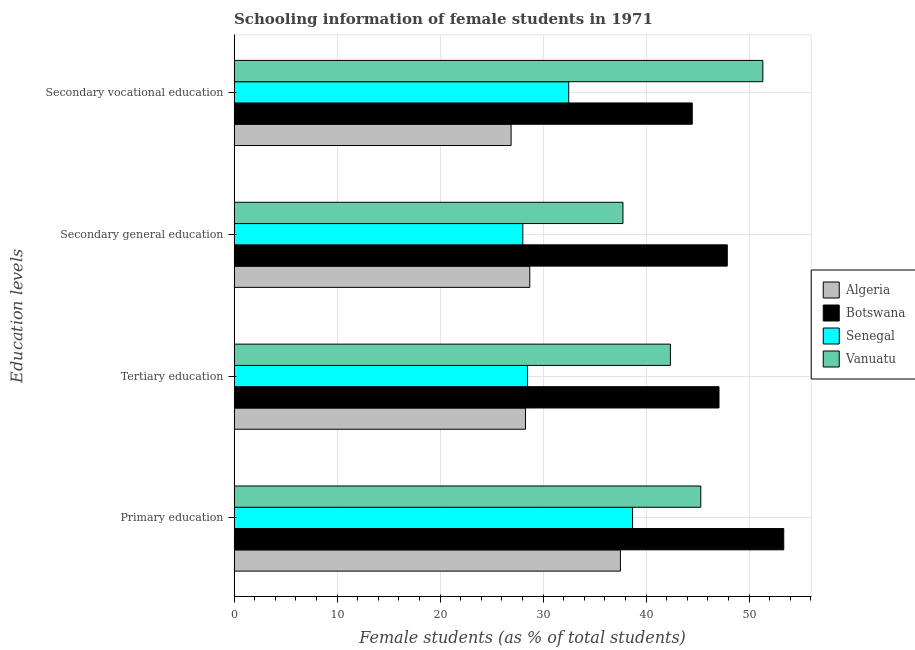How many groups of bars are there?
Your answer should be compact. 4. Are the number of bars on each tick of the Y-axis equal?
Give a very brief answer. Yes. How many bars are there on the 4th tick from the bottom?
Ensure brevity in your answer.  4. What is the label of the 1st group of bars from the top?
Provide a short and direct response. Secondary vocational education. What is the percentage of female students in primary education in Algeria?
Your answer should be very brief. 37.51. Across all countries, what is the maximum percentage of female students in tertiary education?
Offer a terse response. 47.09. Across all countries, what is the minimum percentage of female students in secondary vocational education?
Your answer should be compact. 26.9. In which country was the percentage of female students in secondary vocational education maximum?
Your answer should be very brief. Vanuatu. In which country was the percentage of female students in primary education minimum?
Give a very brief answer. Algeria. What is the total percentage of female students in secondary education in the graph?
Provide a short and direct response. 142.4. What is the difference between the percentage of female students in secondary education in Botswana and that in Algeria?
Ensure brevity in your answer.  19.18. What is the difference between the percentage of female students in primary education in Botswana and the percentage of female students in tertiary education in Senegal?
Your response must be concise. 24.88. What is the average percentage of female students in secondary vocational education per country?
Provide a succinct answer. 38.81. What is the difference between the percentage of female students in secondary vocational education and percentage of female students in secondary education in Vanuatu?
Make the answer very short. 13.58. In how many countries, is the percentage of female students in primary education greater than 18 %?
Offer a very short reply. 4. What is the ratio of the percentage of female students in secondary education in Botswana to that in Vanuatu?
Provide a succinct answer. 1.27. Is the percentage of female students in secondary education in Vanuatu less than that in Botswana?
Offer a terse response. Yes. What is the difference between the highest and the second highest percentage of female students in secondary vocational education?
Make the answer very short. 6.85. What is the difference between the highest and the lowest percentage of female students in secondary education?
Offer a terse response. 19.86. Is it the case that in every country, the sum of the percentage of female students in secondary education and percentage of female students in secondary vocational education is greater than the sum of percentage of female students in primary education and percentage of female students in tertiary education?
Keep it short and to the point. No. What does the 2nd bar from the top in Secondary vocational education represents?
Your response must be concise. Senegal. What does the 4th bar from the bottom in Secondary vocational education represents?
Your response must be concise. Vanuatu. What is the difference between two consecutive major ticks on the X-axis?
Your answer should be very brief. 10. Does the graph contain any zero values?
Make the answer very short. No. Does the graph contain grids?
Keep it short and to the point. Yes. How many legend labels are there?
Keep it short and to the point. 4. How are the legend labels stacked?
Your answer should be very brief. Vertical. What is the title of the graph?
Ensure brevity in your answer.  Schooling information of female students in 1971. What is the label or title of the X-axis?
Your answer should be compact. Female students (as % of total students). What is the label or title of the Y-axis?
Give a very brief answer. Education levels. What is the Female students (as % of total students) in Algeria in Primary education?
Keep it short and to the point. 37.51. What is the Female students (as % of total students) of Botswana in Primary education?
Provide a short and direct response. 53.37. What is the Female students (as % of total students) of Senegal in Primary education?
Provide a succinct answer. 38.69. What is the Female students (as % of total students) in Vanuatu in Primary education?
Your answer should be very brief. 45.32. What is the Female students (as % of total students) of Algeria in Tertiary education?
Provide a succinct answer. 28.29. What is the Female students (as % of total students) of Botswana in Tertiary education?
Provide a short and direct response. 47.09. What is the Female students (as % of total students) in Senegal in Tertiary education?
Provide a succinct answer. 28.49. What is the Female students (as % of total students) of Vanuatu in Tertiary education?
Your answer should be very brief. 42.37. What is the Female students (as % of total students) of Algeria in Secondary general education?
Make the answer very short. 28.71. What is the Female students (as % of total students) of Botswana in Secondary general education?
Your answer should be compact. 47.89. What is the Female students (as % of total students) of Senegal in Secondary general education?
Make the answer very short. 28.03. What is the Female students (as % of total students) in Vanuatu in Secondary general education?
Ensure brevity in your answer.  37.76. What is the Female students (as % of total students) of Algeria in Secondary vocational education?
Ensure brevity in your answer.  26.9. What is the Female students (as % of total students) in Botswana in Secondary vocational education?
Your answer should be very brief. 44.49. What is the Female students (as % of total students) of Senegal in Secondary vocational education?
Offer a terse response. 32.49. What is the Female students (as % of total students) of Vanuatu in Secondary vocational education?
Give a very brief answer. 51.34. Across all Education levels, what is the maximum Female students (as % of total students) of Algeria?
Provide a short and direct response. 37.51. Across all Education levels, what is the maximum Female students (as % of total students) of Botswana?
Provide a short and direct response. 53.37. Across all Education levels, what is the maximum Female students (as % of total students) of Senegal?
Make the answer very short. 38.69. Across all Education levels, what is the maximum Female students (as % of total students) in Vanuatu?
Offer a terse response. 51.34. Across all Education levels, what is the minimum Female students (as % of total students) in Algeria?
Offer a terse response. 26.9. Across all Education levels, what is the minimum Female students (as % of total students) of Botswana?
Offer a very short reply. 44.49. Across all Education levels, what is the minimum Female students (as % of total students) of Senegal?
Your answer should be compact. 28.03. Across all Education levels, what is the minimum Female students (as % of total students) in Vanuatu?
Your answer should be compact. 37.76. What is the total Female students (as % of total students) in Algeria in the graph?
Offer a terse response. 121.41. What is the total Female students (as % of total students) in Botswana in the graph?
Ensure brevity in your answer.  192.84. What is the total Female students (as % of total students) in Senegal in the graph?
Give a very brief answer. 127.71. What is the total Female students (as % of total students) in Vanuatu in the graph?
Your response must be concise. 176.79. What is the difference between the Female students (as % of total students) in Algeria in Primary education and that in Tertiary education?
Make the answer very short. 9.22. What is the difference between the Female students (as % of total students) of Botswana in Primary education and that in Tertiary education?
Give a very brief answer. 6.29. What is the difference between the Female students (as % of total students) in Senegal in Primary education and that in Tertiary education?
Your response must be concise. 10.2. What is the difference between the Female students (as % of total students) in Vanuatu in Primary education and that in Tertiary education?
Make the answer very short. 2.95. What is the difference between the Female students (as % of total students) of Algeria in Primary education and that in Secondary general education?
Ensure brevity in your answer.  8.8. What is the difference between the Female students (as % of total students) in Botswana in Primary education and that in Secondary general education?
Keep it short and to the point. 5.48. What is the difference between the Female students (as % of total students) of Senegal in Primary education and that in Secondary general education?
Your answer should be very brief. 10.66. What is the difference between the Female students (as % of total students) in Vanuatu in Primary education and that in Secondary general education?
Your response must be concise. 7.56. What is the difference between the Female students (as % of total students) in Algeria in Primary education and that in Secondary vocational education?
Provide a short and direct response. 10.62. What is the difference between the Female students (as % of total students) in Botswana in Primary education and that in Secondary vocational education?
Your response must be concise. 8.88. What is the difference between the Female students (as % of total students) in Senegal in Primary education and that in Secondary vocational education?
Your answer should be compact. 6.2. What is the difference between the Female students (as % of total students) of Vanuatu in Primary education and that in Secondary vocational education?
Give a very brief answer. -6.03. What is the difference between the Female students (as % of total students) in Algeria in Tertiary education and that in Secondary general education?
Provide a succinct answer. -0.42. What is the difference between the Female students (as % of total students) in Botswana in Tertiary education and that in Secondary general education?
Your answer should be compact. -0.81. What is the difference between the Female students (as % of total students) of Senegal in Tertiary education and that in Secondary general education?
Offer a terse response. 0.46. What is the difference between the Female students (as % of total students) of Vanuatu in Tertiary education and that in Secondary general education?
Provide a short and direct response. 4.61. What is the difference between the Female students (as % of total students) in Algeria in Tertiary education and that in Secondary vocational education?
Make the answer very short. 1.4. What is the difference between the Female students (as % of total students) of Botswana in Tertiary education and that in Secondary vocational education?
Your answer should be compact. 2.6. What is the difference between the Female students (as % of total students) in Senegal in Tertiary education and that in Secondary vocational education?
Offer a very short reply. -4. What is the difference between the Female students (as % of total students) in Vanuatu in Tertiary education and that in Secondary vocational education?
Your answer should be compact. -8.97. What is the difference between the Female students (as % of total students) in Algeria in Secondary general education and that in Secondary vocational education?
Your answer should be very brief. 1.82. What is the difference between the Female students (as % of total students) in Botswana in Secondary general education and that in Secondary vocational education?
Make the answer very short. 3.4. What is the difference between the Female students (as % of total students) in Senegal in Secondary general education and that in Secondary vocational education?
Make the answer very short. -4.46. What is the difference between the Female students (as % of total students) in Vanuatu in Secondary general education and that in Secondary vocational education?
Make the answer very short. -13.58. What is the difference between the Female students (as % of total students) of Algeria in Primary education and the Female students (as % of total students) of Botswana in Tertiary education?
Provide a short and direct response. -9.57. What is the difference between the Female students (as % of total students) in Algeria in Primary education and the Female students (as % of total students) in Senegal in Tertiary education?
Your answer should be very brief. 9.02. What is the difference between the Female students (as % of total students) in Algeria in Primary education and the Female students (as % of total students) in Vanuatu in Tertiary education?
Your answer should be compact. -4.86. What is the difference between the Female students (as % of total students) in Botswana in Primary education and the Female students (as % of total students) in Senegal in Tertiary education?
Provide a succinct answer. 24.88. What is the difference between the Female students (as % of total students) of Botswana in Primary education and the Female students (as % of total students) of Vanuatu in Tertiary education?
Your answer should be compact. 11. What is the difference between the Female students (as % of total students) in Senegal in Primary education and the Female students (as % of total students) in Vanuatu in Tertiary education?
Provide a succinct answer. -3.68. What is the difference between the Female students (as % of total students) in Algeria in Primary education and the Female students (as % of total students) in Botswana in Secondary general education?
Keep it short and to the point. -10.38. What is the difference between the Female students (as % of total students) of Algeria in Primary education and the Female students (as % of total students) of Senegal in Secondary general education?
Provide a short and direct response. 9.48. What is the difference between the Female students (as % of total students) in Algeria in Primary education and the Female students (as % of total students) in Vanuatu in Secondary general education?
Offer a terse response. -0.25. What is the difference between the Female students (as % of total students) of Botswana in Primary education and the Female students (as % of total students) of Senegal in Secondary general education?
Keep it short and to the point. 25.34. What is the difference between the Female students (as % of total students) of Botswana in Primary education and the Female students (as % of total students) of Vanuatu in Secondary general education?
Provide a short and direct response. 15.61. What is the difference between the Female students (as % of total students) of Senegal in Primary education and the Female students (as % of total students) of Vanuatu in Secondary general education?
Offer a very short reply. 0.93. What is the difference between the Female students (as % of total students) of Algeria in Primary education and the Female students (as % of total students) of Botswana in Secondary vocational education?
Your answer should be compact. -6.98. What is the difference between the Female students (as % of total students) of Algeria in Primary education and the Female students (as % of total students) of Senegal in Secondary vocational education?
Your answer should be very brief. 5.02. What is the difference between the Female students (as % of total students) of Algeria in Primary education and the Female students (as % of total students) of Vanuatu in Secondary vocational education?
Give a very brief answer. -13.83. What is the difference between the Female students (as % of total students) of Botswana in Primary education and the Female students (as % of total students) of Senegal in Secondary vocational education?
Give a very brief answer. 20.88. What is the difference between the Female students (as % of total students) in Botswana in Primary education and the Female students (as % of total students) in Vanuatu in Secondary vocational education?
Provide a short and direct response. 2.03. What is the difference between the Female students (as % of total students) in Senegal in Primary education and the Female students (as % of total students) in Vanuatu in Secondary vocational education?
Offer a very short reply. -12.65. What is the difference between the Female students (as % of total students) of Algeria in Tertiary education and the Female students (as % of total students) of Botswana in Secondary general education?
Offer a very short reply. -19.6. What is the difference between the Female students (as % of total students) of Algeria in Tertiary education and the Female students (as % of total students) of Senegal in Secondary general education?
Your answer should be compact. 0.26. What is the difference between the Female students (as % of total students) in Algeria in Tertiary education and the Female students (as % of total students) in Vanuatu in Secondary general education?
Your answer should be compact. -9.47. What is the difference between the Female students (as % of total students) in Botswana in Tertiary education and the Female students (as % of total students) in Senegal in Secondary general education?
Offer a very short reply. 19.05. What is the difference between the Female students (as % of total students) in Botswana in Tertiary education and the Female students (as % of total students) in Vanuatu in Secondary general education?
Your response must be concise. 9.33. What is the difference between the Female students (as % of total students) in Senegal in Tertiary education and the Female students (as % of total students) in Vanuatu in Secondary general education?
Provide a short and direct response. -9.27. What is the difference between the Female students (as % of total students) of Algeria in Tertiary education and the Female students (as % of total students) of Botswana in Secondary vocational education?
Ensure brevity in your answer.  -16.2. What is the difference between the Female students (as % of total students) of Algeria in Tertiary education and the Female students (as % of total students) of Senegal in Secondary vocational education?
Make the answer very short. -4.2. What is the difference between the Female students (as % of total students) of Algeria in Tertiary education and the Female students (as % of total students) of Vanuatu in Secondary vocational education?
Your response must be concise. -23.05. What is the difference between the Female students (as % of total students) in Botswana in Tertiary education and the Female students (as % of total students) in Senegal in Secondary vocational education?
Ensure brevity in your answer.  14.59. What is the difference between the Female students (as % of total students) in Botswana in Tertiary education and the Female students (as % of total students) in Vanuatu in Secondary vocational education?
Keep it short and to the point. -4.26. What is the difference between the Female students (as % of total students) in Senegal in Tertiary education and the Female students (as % of total students) in Vanuatu in Secondary vocational education?
Ensure brevity in your answer.  -22.85. What is the difference between the Female students (as % of total students) in Algeria in Secondary general education and the Female students (as % of total students) in Botswana in Secondary vocational education?
Provide a short and direct response. -15.78. What is the difference between the Female students (as % of total students) in Algeria in Secondary general education and the Female students (as % of total students) in Senegal in Secondary vocational education?
Ensure brevity in your answer.  -3.78. What is the difference between the Female students (as % of total students) of Algeria in Secondary general education and the Female students (as % of total students) of Vanuatu in Secondary vocational education?
Provide a succinct answer. -22.63. What is the difference between the Female students (as % of total students) of Botswana in Secondary general education and the Female students (as % of total students) of Senegal in Secondary vocational education?
Your response must be concise. 15.4. What is the difference between the Female students (as % of total students) in Botswana in Secondary general education and the Female students (as % of total students) in Vanuatu in Secondary vocational education?
Provide a succinct answer. -3.45. What is the difference between the Female students (as % of total students) in Senegal in Secondary general education and the Female students (as % of total students) in Vanuatu in Secondary vocational education?
Your answer should be compact. -23.31. What is the average Female students (as % of total students) in Algeria per Education levels?
Your answer should be very brief. 30.35. What is the average Female students (as % of total students) in Botswana per Education levels?
Offer a very short reply. 48.21. What is the average Female students (as % of total students) in Senegal per Education levels?
Provide a succinct answer. 31.93. What is the average Female students (as % of total students) of Vanuatu per Education levels?
Give a very brief answer. 44.2. What is the difference between the Female students (as % of total students) in Algeria and Female students (as % of total students) in Botswana in Primary education?
Your answer should be compact. -15.86. What is the difference between the Female students (as % of total students) in Algeria and Female students (as % of total students) in Senegal in Primary education?
Provide a short and direct response. -1.18. What is the difference between the Female students (as % of total students) in Algeria and Female students (as % of total students) in Vanuatu in Primary education?
Give a very brief answer. -7.8. What is the difference between the Female students (as % of total students) in Botswana and Female students (as % of total students) in Senegal in Primary education?
Give a very brief answer. 14.68. What is the difference between the Female students (as % of total students) in Botswana and Female students (as % of total students) in Vanuatu in Primary education?
Keep it short and to the point. 8.06. What is the difference between the Female students (as % of total students) of Senegal and Female students (as % of total students) of Vanuatu in Primary education?
Your answer should be compact. -6.62. What is the difference between the Female students (as % of total students) of Algeria and Female students (as % of total students) of Botswana in Tertiary education?
Your answer should be very brief. -18.79. What is the difference between the Female students (as % of total students) of Algeria and Female students (as % of total students) of Senegal in Tertiary education?
Provide a short and direct response. -0.2. What is the difference between the Female students (as % of total students) of Algeria and Female students (as % of total students) of Vanuatu in Tertiary education?
Provide a short and direct response. -14.08. What is the difference between the Female students (as % of total students) of Botswana and Female students (as % of total students) of Senegal in Tertiary education?
Keep it short and to the point. 18.59. What is the difference between the Female students (as % of total students) of Botswana and Female students (as % of total students) of Vanuatu in Tertiary education?
Offer a very short reply. 4.72. What is the difference between the Female students (as % of total students) in Senegal and Female students (as % of total students) in Vanuatu in Tertiary education?
Offer a very short reply. -13.88. What is the difference between the Female students (as % of total students) in Algeria and Female students (as % of total students) in Botswana in Secondary general education?
Give a very brief answer. -19.18. What is the difference between the Female students (as % of total students) of Algeria and Female students (as % of total students) of Senegal in Secondary general education?
Make the answer very short. 0.68. What is the difference between the Female students (as % of total students) of Algeria and Female students (as % of total students) of Vanuatu in Secondary general education?
Offer a very short reply. -9.05. What is the difference between the Female students (as % of total students) of Botswana and Female students (as % of total students) of Senegal in Secondary general education?
Your answer should be compact. 19.86. What is the difference between the Female students (as % of total students) in Botswana and Female students (as % of total students) in Vanuatu in Secondary general education?
Your answer should be compact. 10.13. What is the difference between the Female students (as % of total students) of Senegal and Female students (as % of total students) of Vanuatu in Secondary general education?
Keep it short and to the point. -9.72. What is the difference between the Female students (as % of total students) of Algeria and Female students (as % of total students) of Botswana in Secondary vocational education?
Ensure brevity in your answer.  -17.59. What is the difference between the Female students (as % of total students) in Algeria and Female students (as % of total students) in Senegal in Secondary vocational education?
Give a very brief answer. -5.6. What is the difference between the Female students (as % of total students) of Algeria and Female students (as % of total students) of Vanuatu in Secondary vocational education?
Provide a succinct answer. -24.45. What is the difference between the Female students (as % of total students) of Botswana and Female students (as % of total students) of Senegal in Secondary vocational education?
Keep it short and to the point. 12. What is the difference between the Female students (as % of total students) in Botswana and Female students (as % of total students) in Vanuatu in Secondary vocational education?
Offer a terse response. -6.85. What is the difference between the Female students (as % of total students) of Senegal and Female students (as % of total students) of Vanuatu in Secondary vocational education?
Provide a short and direct response. -18.85. What is the ratio of the Female students (as % of total students) in Algeria in Primary education to that in Tertiary education?
Your answer should be compact. 1.33. What is the ratio of the Female students (as % of total students) of Botswana in Primary education to that in Tertiary education?
Give a very brief answer. 1.13. What is the ratio of the Female students (as % of total students) of Senegal in Primary education to that in Tertiary education?
Provide a short and direct response. 1.36. What is the ratio of the Female students (as % of total students) of Vanuatu in Primary education to that in Tertiary education?
Your response must be concise. 1.07. What is the ratio of the Female students (as % of total students) of Algeria in Primary education to that in Secondary general education?
Offer a very short reply. 1.31. What is the ratio of the Female students (as % of total students) of Botswana in Primary education to that in Secondary general education?
Your answer should be very brief. 1.11. What is the ratio of the Female students (as % of total students) in Senegal in Primary education to that in Secondary general education?
Provide a succinct answer. 1.38. What is the ratio of the Female students (as % of total students) of Vanuatu in Primary education to that in Secondary general education?
Provide a short and direct response. 1.2. What is the ratio of the Female students (as % of total students) of Algeria in Primary education to that in Secondary vocational education?
Ensure brevity in your answer.  1.39. What is the ratio of the Female students (as % of total students) of Botswana in Primary education to that in Secondary vocational education?
Give a very brief answer. 1.2. What is the ratio of the Female students (as % of total students) of Senegal in Primary education to that in Secondary vocational education?
Ensure brevity in your answer.  1.19. What is the ratio of the Female students (as % of total students) of Vanuatu in Primary education to that in Secondary vocational education?
Your answer should be compact. 0.88. What is the ratio of the Female students (as % of total students) of Algeria in Tertiary education to that in Secondary general education?
Offer a terse response. 0.99. What is the ratio of the Female students (as % of total students) of Botswana in Tertiary education to that in Secondary general education?
Offer a very short reply. 0.98. What is the ratio of the Female students (as % of total students) in Senegal in Tertiary education to that in Secondary general education?
Offer a terse response. 1.02. What is the ratio of the Female students (as % of total students) in Vanuatu in Tertiary education to that in Secondary general education?
Make the answer very short. 1.12. What is the ratio of the Female students (as % of total students) in Algeria in Tertiary education to that in Secondary vocational education?
Make the answer very short. 1.05. What is the ratio of the Female students (as % of total students) in Botswana in Tertiary education to that in Secondary vocational education?
Make the answer very short. 1.06. What is the ratio of the Female students (as % of total students) of Senegal in Tertiary education to that in Secondary vocational education?
Your answer should be compact. 0.88. What is the ratio of the Female students (as % of total students) in Vanuatu in Tertiary education to that in Secondary vocational education?
Offer a terse response. 0.83. What is the ratio of the Female students (as % of total students) in Algeria in Secondary general education to that in Secondary vocational education?
Ensure brevity in your answer.  1.07. What is the ratio of the Female students (as % of total students) of Botswana in Secondary general education to that in Secondary vocational education?
Ensure brevity in your answer.  1.08. What is the ratio of the Female students (as % of total students) of Senegal in Secondary general education to that in Secondary vocational education?
Give a very brief answer. 0.86. What is the ratio of the Female students (as % of total students) in Vanuatu in Secondary general education to that in Secondary vocational education?
Provide a succinct answer. 0.74. What is the difference between the highest and the second highest Female students (as % of total students) of Algeria?
Offer a very short reply. 8.8. What is the difference between the highest and the second highest Female students (as % of total students) of Botswana?
Your answer should be very brief. 5.48. What is the difference between the highest and the second highest Female students (as % of total students) in Senegal?
Your answer should be compact. 6.2. What is the difference between the highest and the second highest Female students (as % of total students) in Vanuatu?
Provide a short and direct response. 6.03. What is the difference between the highest and the lowest Female students (as % of total students) of Algeria?
Provide a succinct answer. 10.62. What is the difference between the highest and the lowest Female students (as % of total students) of Botswana?
Offer a very short reply. 8.88. What is the difference between the highest and the lowest Female students (as % of total students) in Senegal?
Offer a very short reply. 10.66. What is the difference between the highest and the lowest Female students (as % of total students) in Vanuatu?
Give a very brief answer. 13.58. 